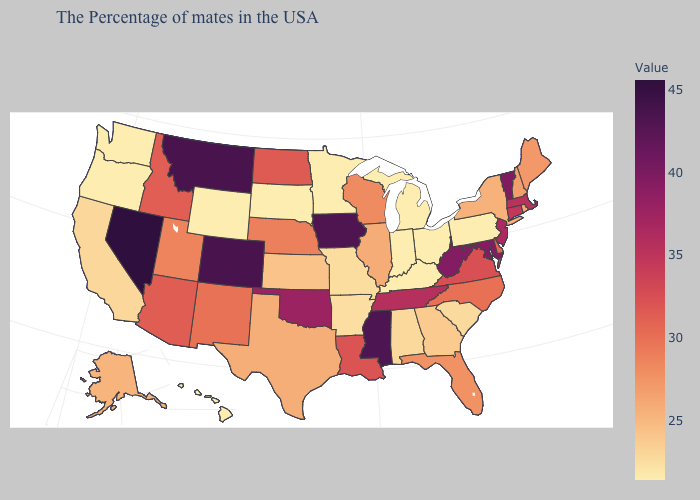Among the states that border Utah , does Nevada have the highest value?
Be succinct. Yes. Does Arizona have a lower value than Maine?
Be succinct. No. Which states have the lowest value in the MidWest?
Answer briefly. Ohio, Michigan, Indiana, Minnesota, South Dakota. Does Nevada have the highest value in the USA?
Short answer required. Yes. Which states have the highest value in the USA?
Answer briefly. Nevada. Which states hav the highest value in the Northeast?
Be succinct. Vermont. 